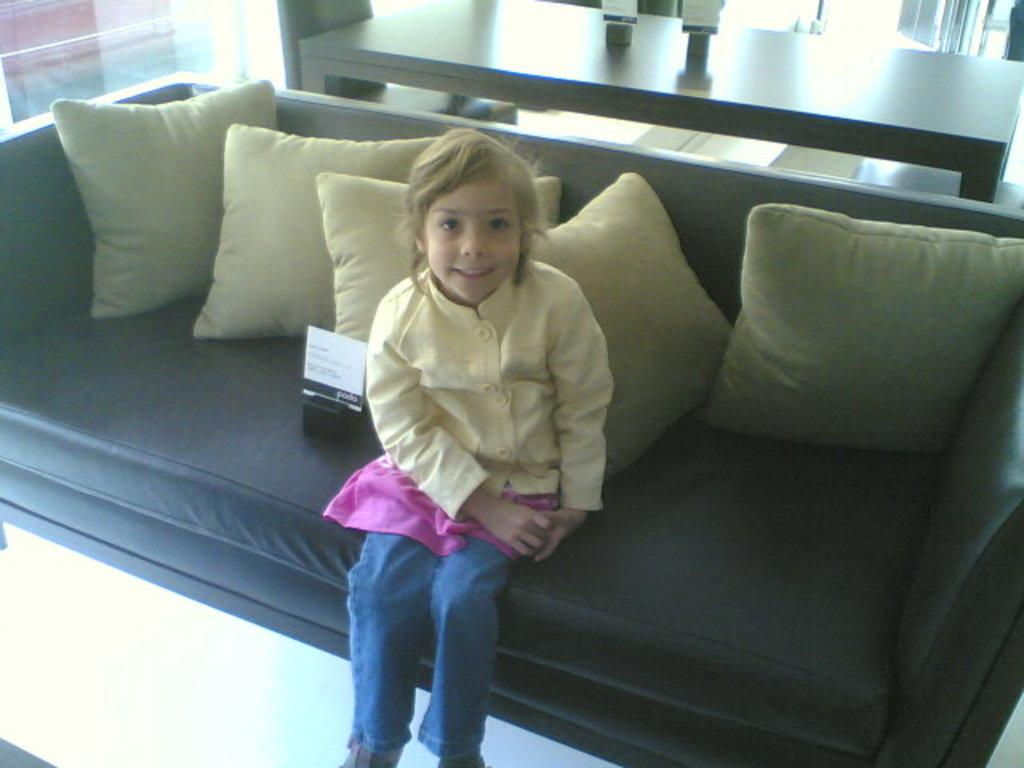Who is the main subject in the image? There is a girl in the image. What is the girl wearing? The girl is wearing a yellow shirt. What is the girl doing in the image? The girl is laughing. Where is the girl sitting? The girl is sitting on a sofa. What can be seen on the sofa with the girl? There are pillows in the image. What is the purpose of the table in the image? There is a table in the image, which might be used for placing items or as a surface for activities. What is the girl holding in the image? There is a glass in the image, which might be held by the girl. What other items can be seen in the image? There are other items in the image, but their specific details are not mentioned in the provided facts. What is visible beneath the girl and the sofa? There is a floor visible in the image. What type of agreement did the girl and her partner reach in the image? There is no mention of a partner or any agreement in the image. The girl is simply sitting on a sofa, laughing, and holding a glass. 